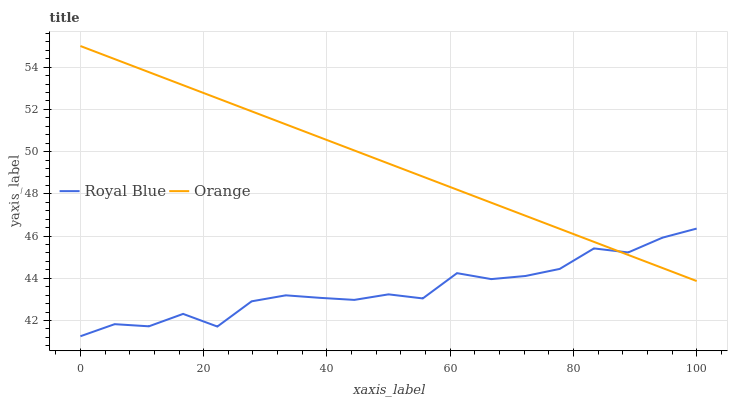Does Royal Blue have the minimum area under the curve?
Answer yes or no. Yes. Does Orange have the maximum area under the curve?
Answer yes or no. Yes. Does Royal Blue have the maximum area under the curve?
Answer yes or no. No. Is Orange the smoothest?
Answer yes or no. Yes. Is Royal Blue the roughest?
Answer yes or no. Yes. Is Royal Blue the smoothest?
Answer yes or no. No. Does Royal Blue have the lowest value?
Answer yes or no. Yes. Does Orange have the highest value?
Answer yes or no. Yes. Does Royal Blue have the highest value?
Answer yes or no. No. Does Royal Blue intersect Orange?
Answer yes or no. Yes. Is Royal Blue less than Orange?
Answer yes or no. No. Is Royal Blue greater than Orange?
Answer yes or no. No. 